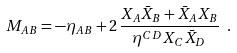Convert formula to latex. <formula><loc_0><loc_0><loc_500><loc_500>M _ { A B } = - \eta _ { A B } + 2 \, \frac { X _ { A } \bar { X } _ { B } + \bar { X } _ { A } X _ { B } } { \eta ^ { C D } X _ { C } \bar { X } _ { D } } \ .</formula> 